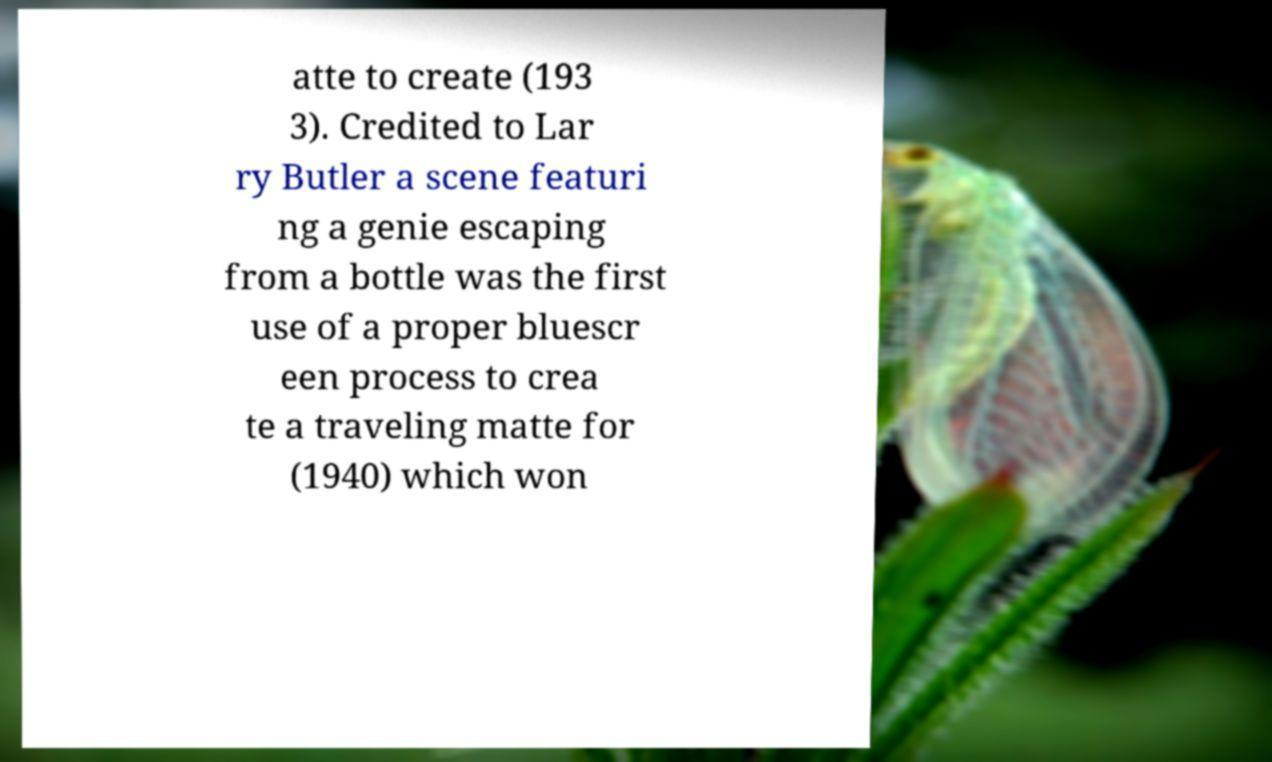Could you extract and type out the text from this image? atte to create (193 3). Credited to Lar ry Butler a scene featuri ng a genie escaping from a bottle was the first use of a proper bluescr een process to crea te a traveling matte for (1940) which won 